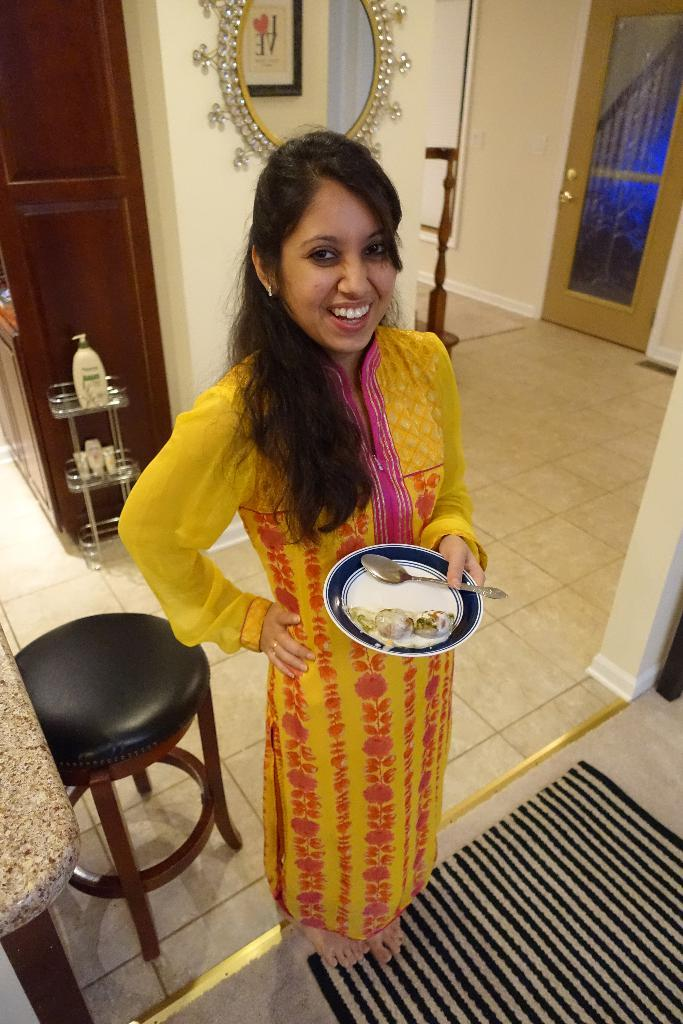Who is present in the image? There is a woman in the image. What is the woman doing in the image? The woman is standing in the image. What objects is the woman holding? The woman is holding a plate and a spoon in the image. What furniture can be seen in the image? There is a table in the image. What reflective surface is present in the image? There is a mirror in the image. How long does it take for the woman to set the bait in the image? There is no mention of bait or any activity related to setting bait in the image. 